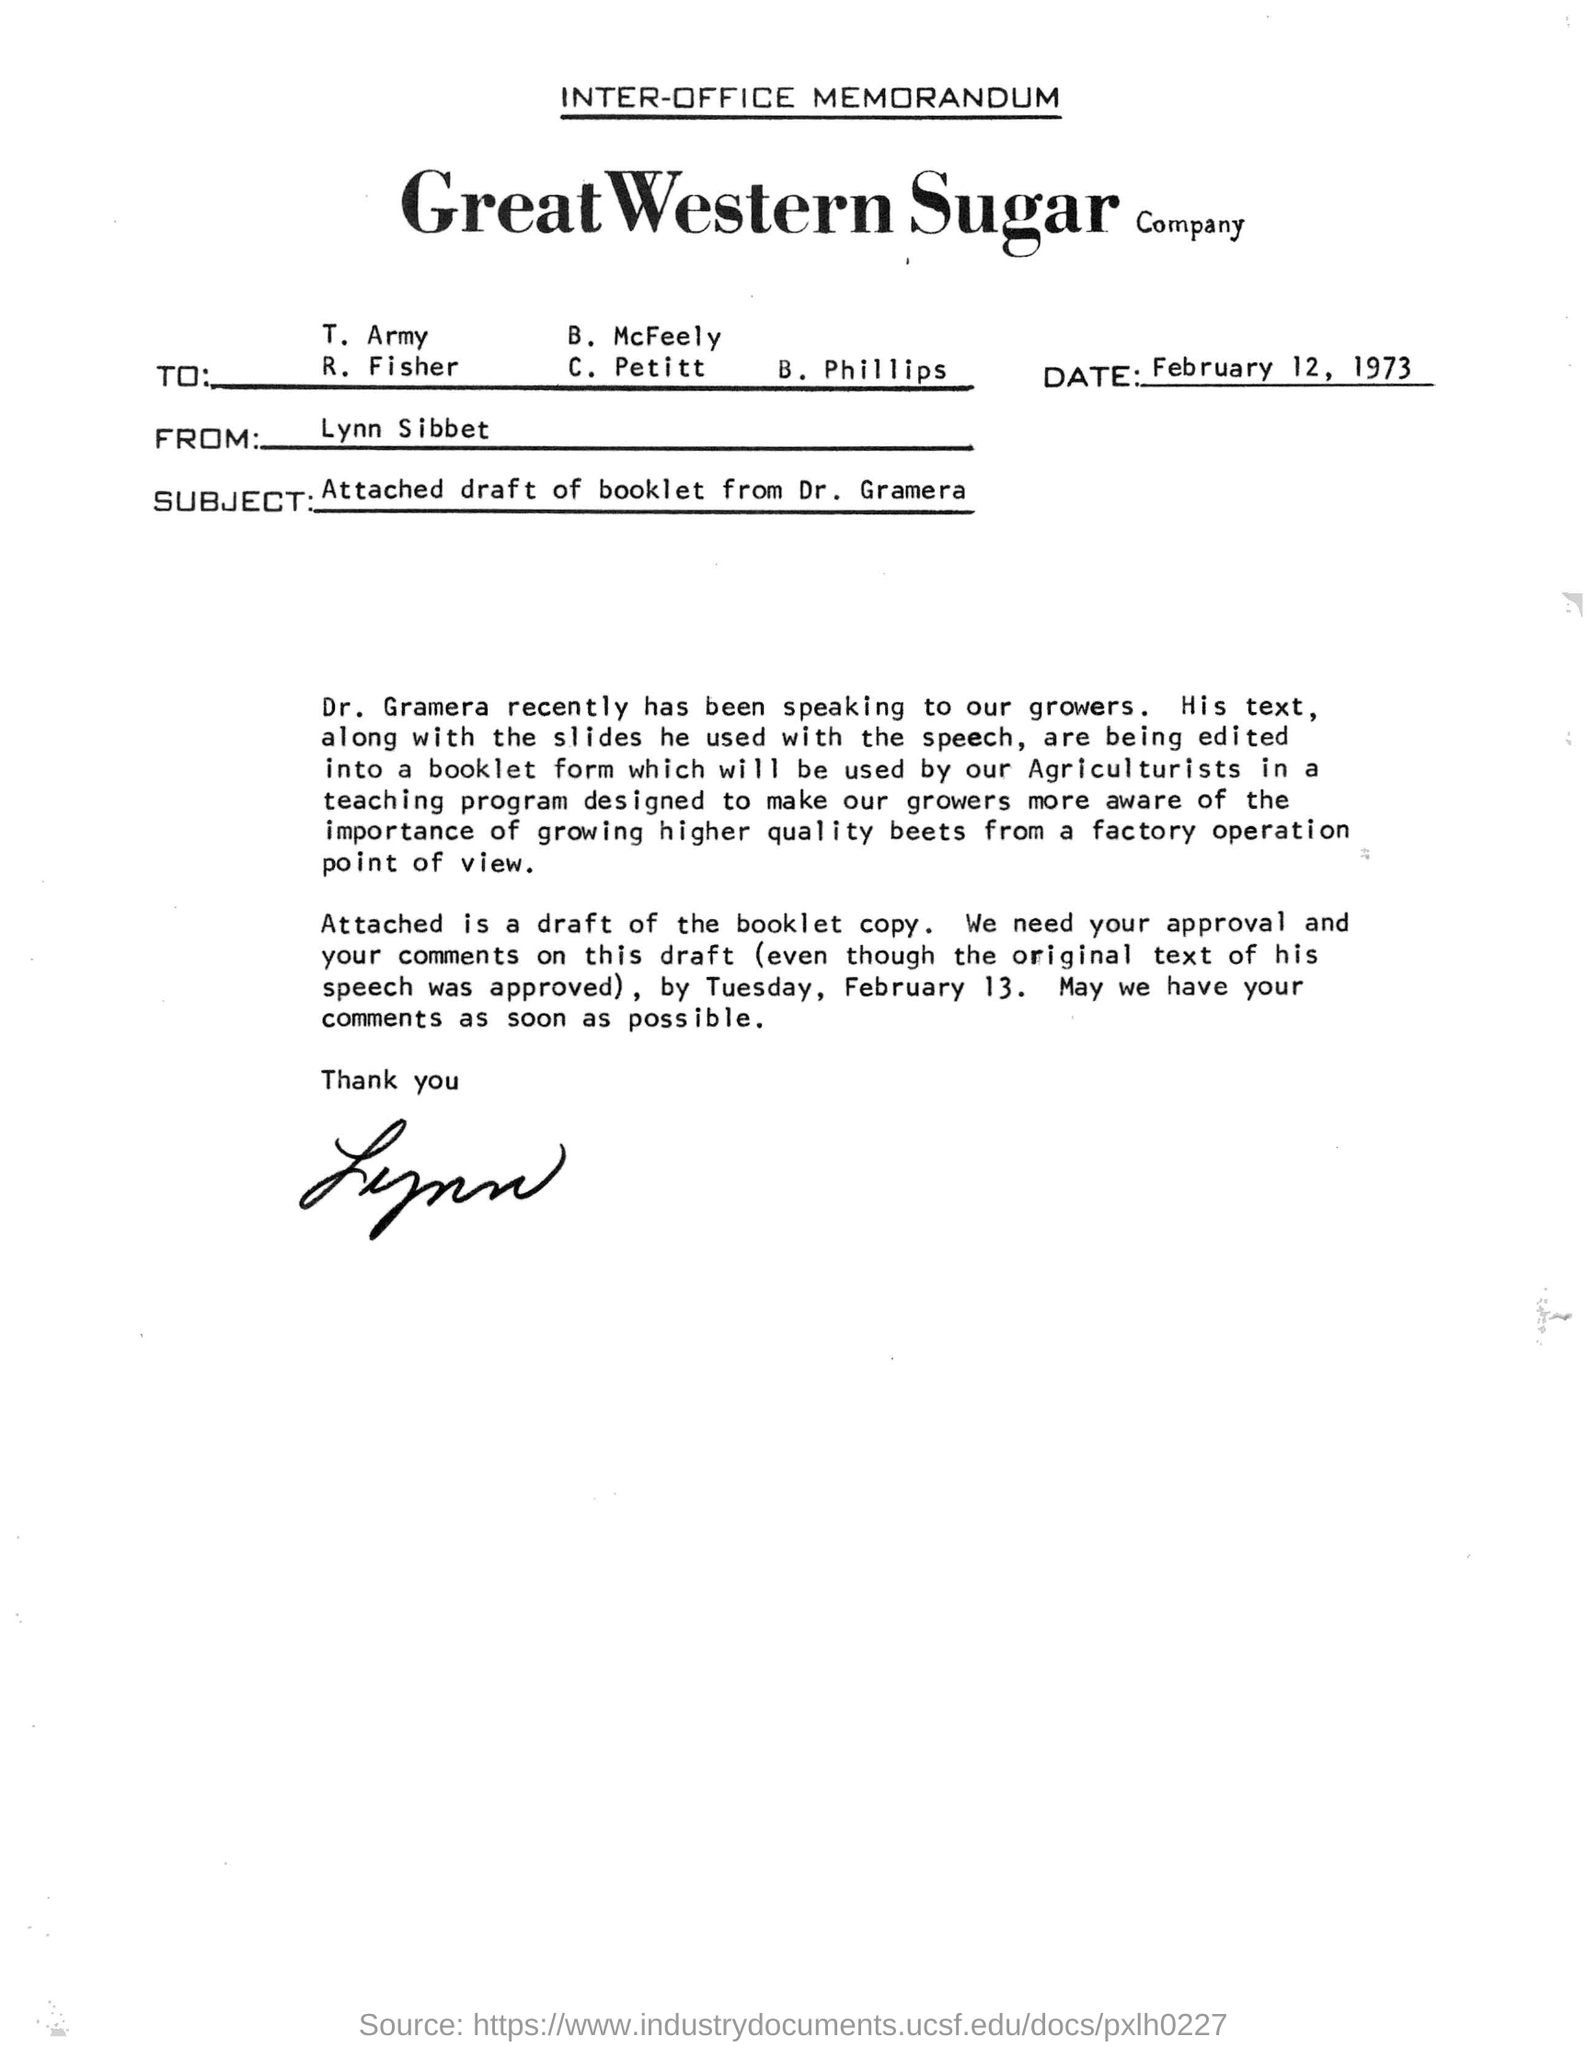Who is the memorandum from?
Ensure brevity in your answer.  Lynn Sibbet. What is the date in the memorandum?
Provide a succinct answer. February 12, 1973. 